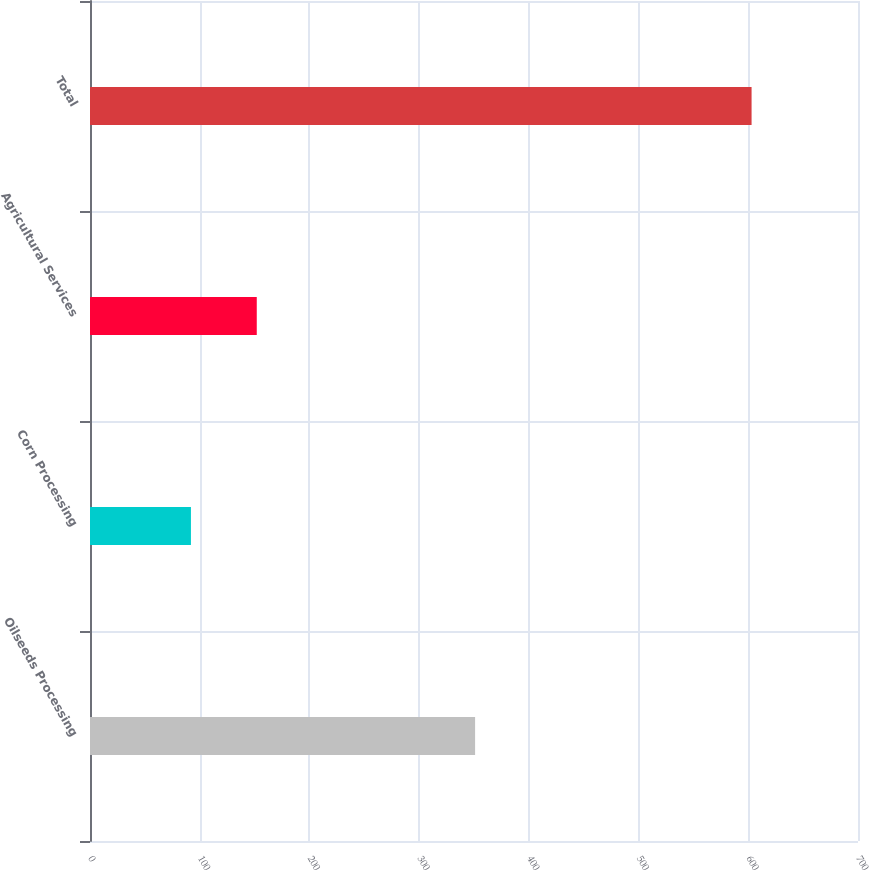Convert chart. <chart><loc_0><loc_0><loc_500><loc_500><bar_chart><fcel>Oilseeds Processing<fcel>Corn Processing<fcel>Agricultural Services<fcel>Total<nl><fcel>351<fcel>92<fcel>152<fcel>603<nl></chart> 